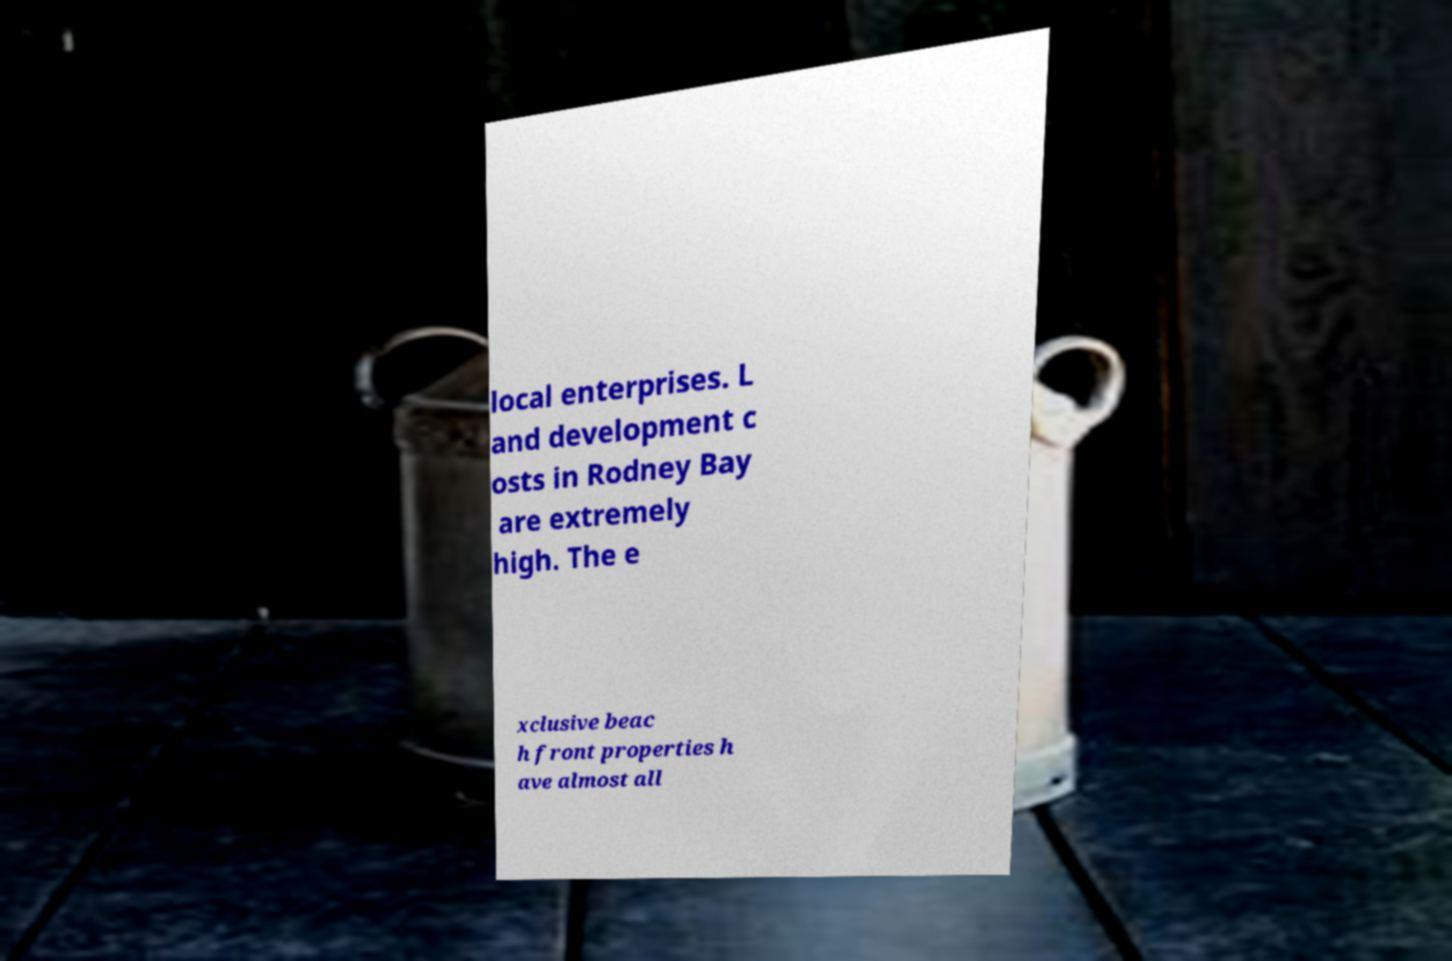Please identify and transcribe the text found in this image. local enterprises. L and development c osts in Rodney Bay are extremely high. The e xclusive beac h front properties h ave almost all 